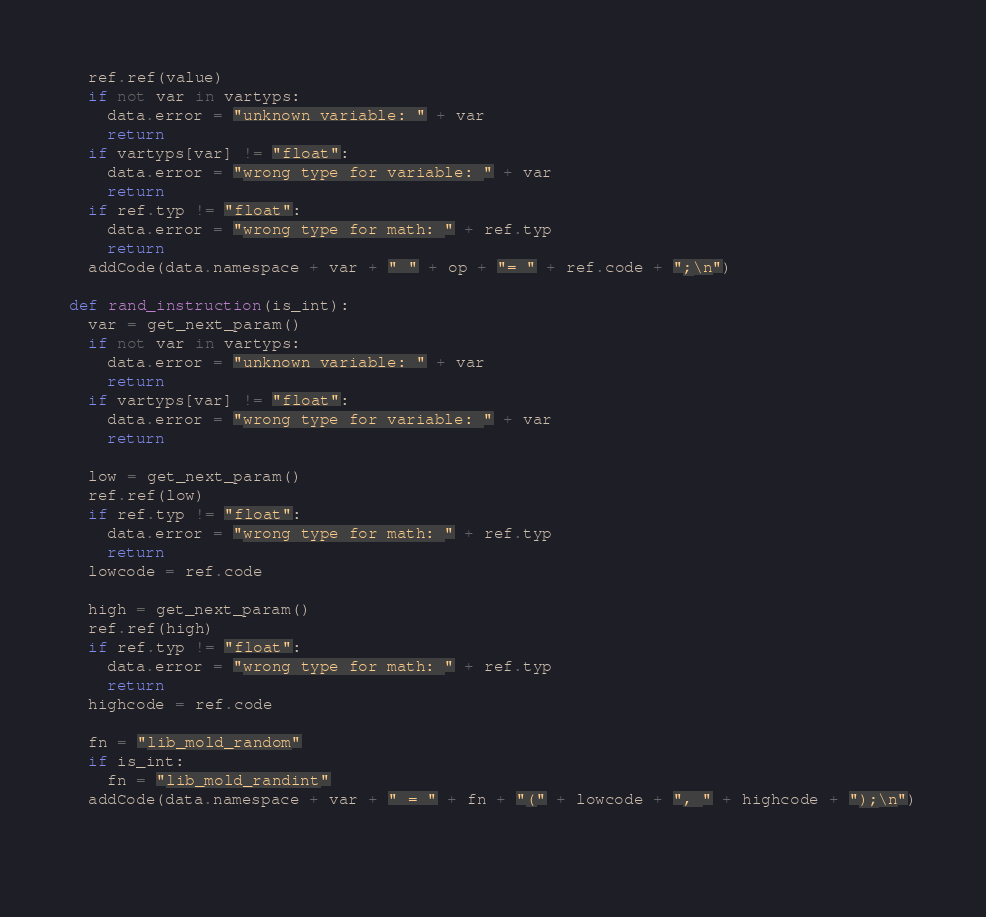Convert code to text. <code><loc_0><loc_0><loc_500><loc_500><_Python_>  ref.ref(value)
  if not var in vartyps:
    data.error = "unknown variable: " + var
    return
  if vartyps[var] != "float":
    data.error = "wrong type for variable: " + var
    return
  if ref.typ != "float":
    data.error = "wrong type for math: " + ref.typ
    return
  addCode(data.namespace + var + " " + op + "= " + ref.code + ";\n")

def rand_instruction(is_int):
  var = get_next_param()
  if not var in vartyps:
    data.error = "unknown variable: " + var
    return
  if vartyps[var] != "float":
    data.error = "wrong type for variable: " + var
    return
  
  low = get_next_param()
  ref.ref(low)
  if ref.typ != "float":
    data.error = "wrong type for math: " + ref.typ
    return
  lowcode = ref.code  

  high = get_next_param()
  ref.ref(high)
  if ref.typ != "float":
    data.error = "wrong type for math: " + ref.typ
    return
  highcode = ref.code
  
  fn = "lib_mold_random"
  if is_int:
    fn = "lib_mold_randint"
  addCode(data.namespace + var + " = " + fn + "(" + lowcode + ", " + highcode + ");\n")
  
  </code> 